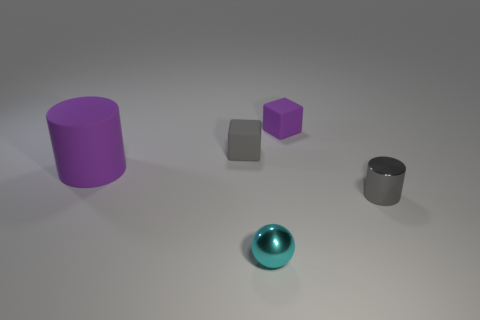Add 1 tiny objects. How many objects exist? 6 Subtract all balls. How many objects are left? 4 Add 4 gray rubber things. How many gray rubber things are left? 5 Add 4 blocks. How many blocks exist? 6 Subtract 1 cyan spheres. How many objects are left? 4 Subtract all large metal blocks. Subtract all gray matte objects. How many objects are left? 4 